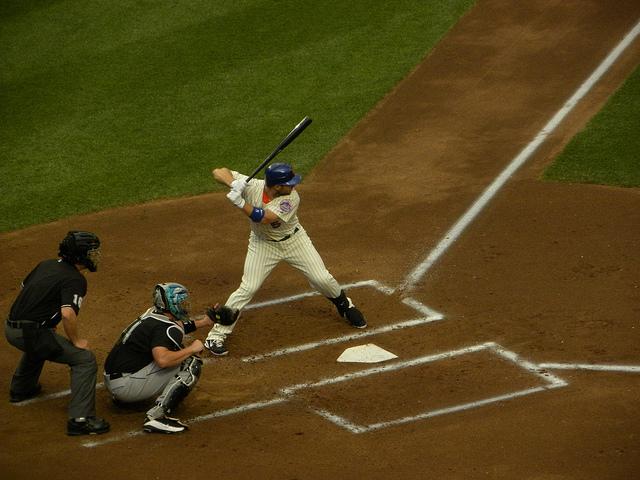What is the person in white holding?
Give a very brief answer. Bat. What game are they playing?
Be succinct. Baseball. What is the color of the catcher's hat?
Answer briefly. Blue. 